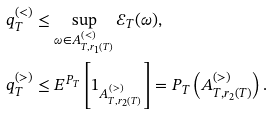Convert formula to latex. <formula><loc_0><loc_0><loc_500><loc_500>q _ { T } ^ { ( < ) } & \leq \sup _ { \omega \in A ^ { ( < ) } _ { T , r _ { 1 } ( T ) } } \mathcal { E } _ { T } ( \omega ) , \\ q _ { T } ^ { ( > ) } & \leq E ^ { P _ { T } } \left [ 1 _ { A ^ { ( > ) } _ { T , r _ { 2 } ( T ) } } \right ] = P _ { T } \left ( A ^ { ( > ) } _ { T , r _ { 2 } ( T ) } \right ) .</formula> 